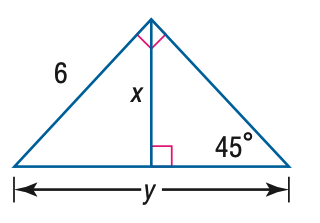Answer the mathemtical geometry problem and directly provide the correct option letter.
Question: Find y.
Choices: A: 3 \sqrt { 2 } B: 6 \sqrt { 2 } C: 6 \sqrt { 3 } D: 12 B 